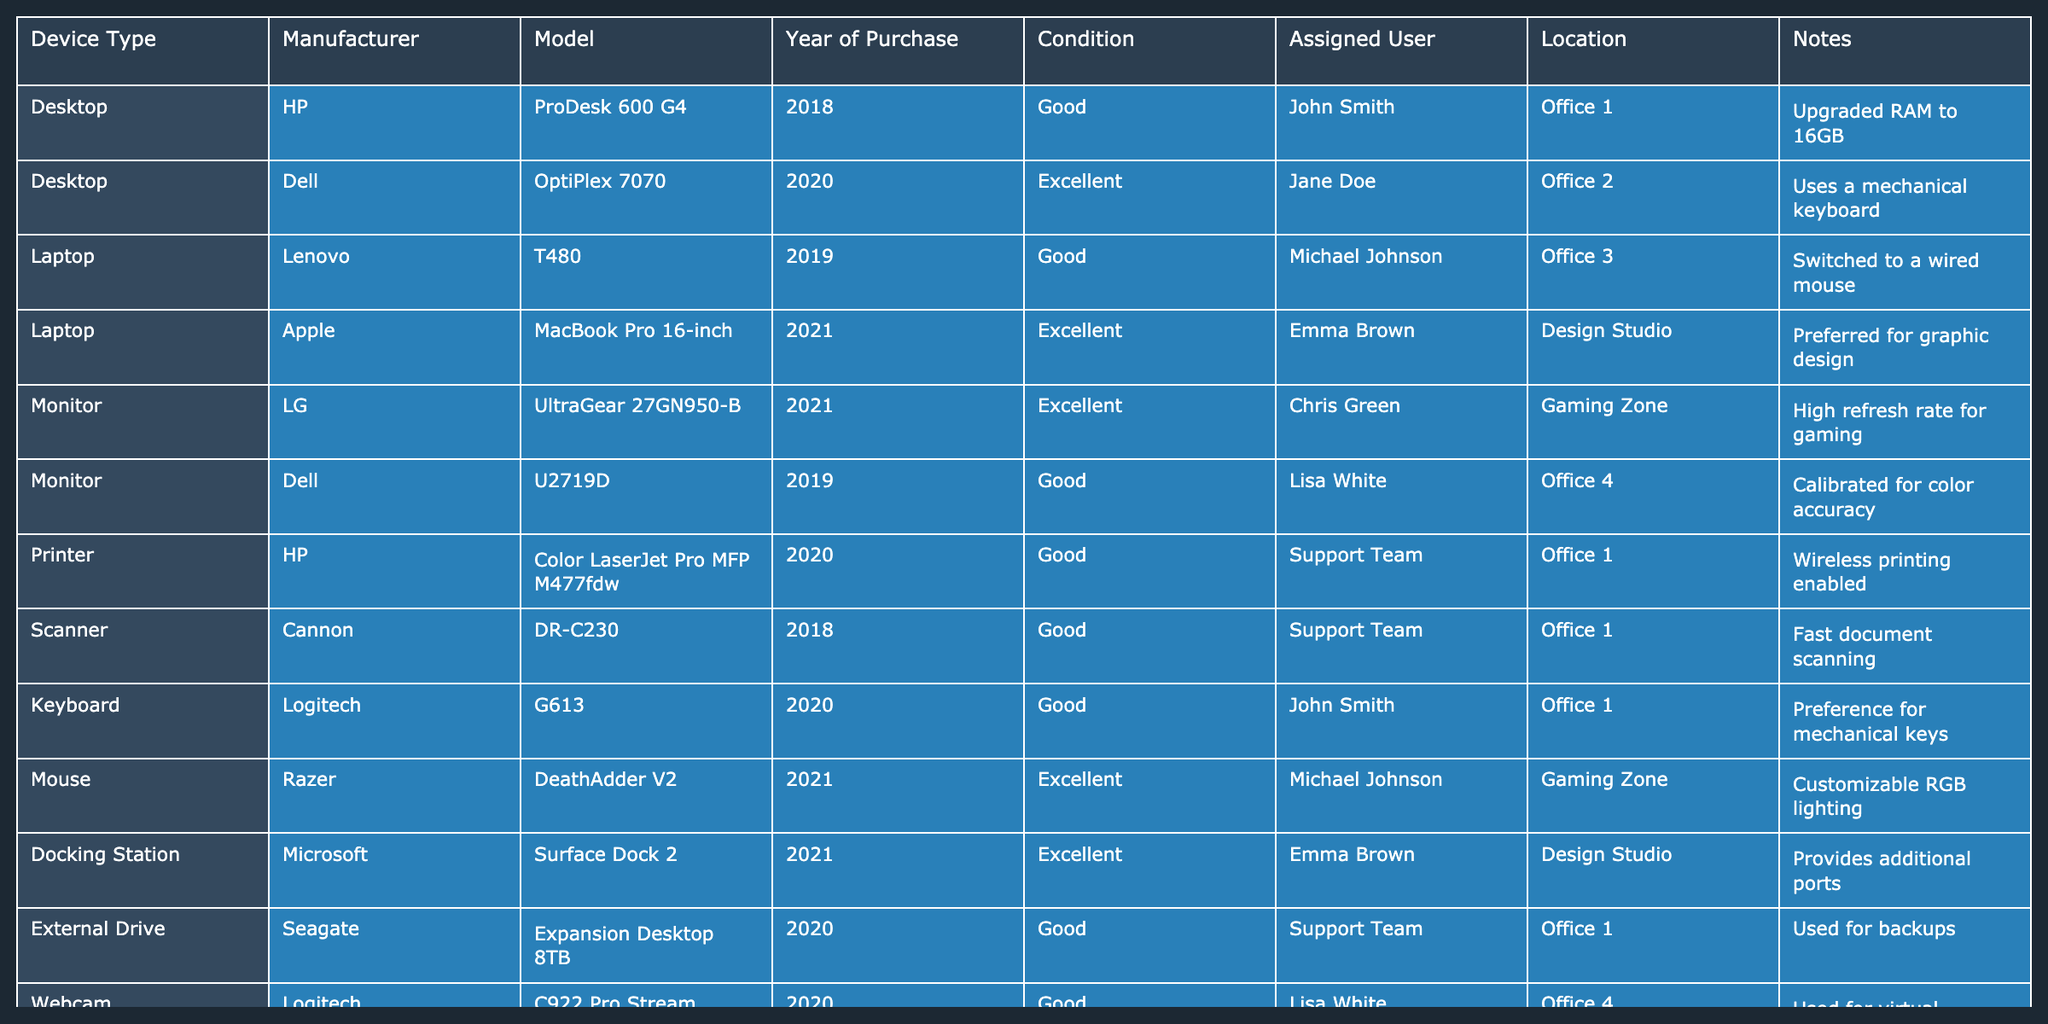What models of laptops are currently in use? By examining the "Device Type" and "Model" columns in the table, we can identify that there are two laptop models currently in use: Lenovo T480 and Apple MacBook Pro 16-inch.
Answer: Lenovo T480, Apple MacBook Pro 16-inch How many devices are in good condition? We can count the entries in the "Condition" column marked as "Good". There are a total of 7 devices listed as being in good condition in the table.
Answer: 7 Is there any device assigned to Lisa White? Looking at the "Assigned User" column, Lisa White is assigned to two devices: Dell U2719D monitor and Logitech C922 Pro Stream webcam. Therefore, the answer is yes.
Answer: Yes What is the total number of desktop devices? Scanning the "Device Type" column for entries listed as "Desktop", we find there are 2 desktops: HP ProDesk 600 G4 and Dell OptiPlex 7070, so the total number is 2.
Answer: 2 What is the average year of purchase for all devices? Adding the years of purchase (2018 + 2020 + 2019 + 2021 + 2021 + 2019 + 2020 + 2018 + 2020 + 2020 + 2021 + 2020 + 2020 + 2020 + 2018) gives us 35 years. Dividing by the number of devices (15) gives an average year of purchase of 35/15 = 2.33, which translates to 2019.33.
Answer: Approximately 2019 How many devices are located in the Server Room? Reviewing the "Location" column, we see that there are 2 devices (TP-Link Archer AX6000 router and Cisco Catalyst 2960-X networking switch) located in the Server Room.
Answer: 2 What is the condition of the printer? The "Condition" column indicates that the printer HP Color LaserJet Pro MFP M477fdw is marked as "Good".
Answer: Good Which assigned user has the highest number of devices? By tallying the devices per user in the "Assigned User" column, we find that Emma Brown has 3 devices assigned: MacBook Pro, Microsoft Surface Dock 2, and Blue Yeti microphone, which is more than any other user.
Answer: Emma Brown Are all the laptops in excellent condition? Checking the "Condition" column for all laptops, we find that only the Apple MacBook Pro is in excellent condition, while the Lenovo T480 is in good condition, meaning not all laptops are in excellent condition.
Answer: No What device has been upgraded to 16GB of RAM? Referring to the "Notes" column, we see that the HP ProDesk 600 G4 desktop has been upgraded to 16GB of RAM.
Answer: HP ProDesk 600 G4 